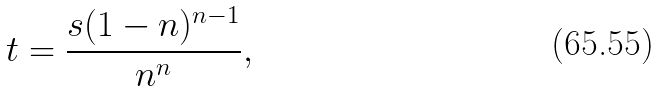Convert formula to latex. <formula><loc_0><loc_0><loc_500><loc_500>t = { \frac { s ( 1 - n ) ^ { n - 1 } } { n ^ { n } } } ,</formula> 